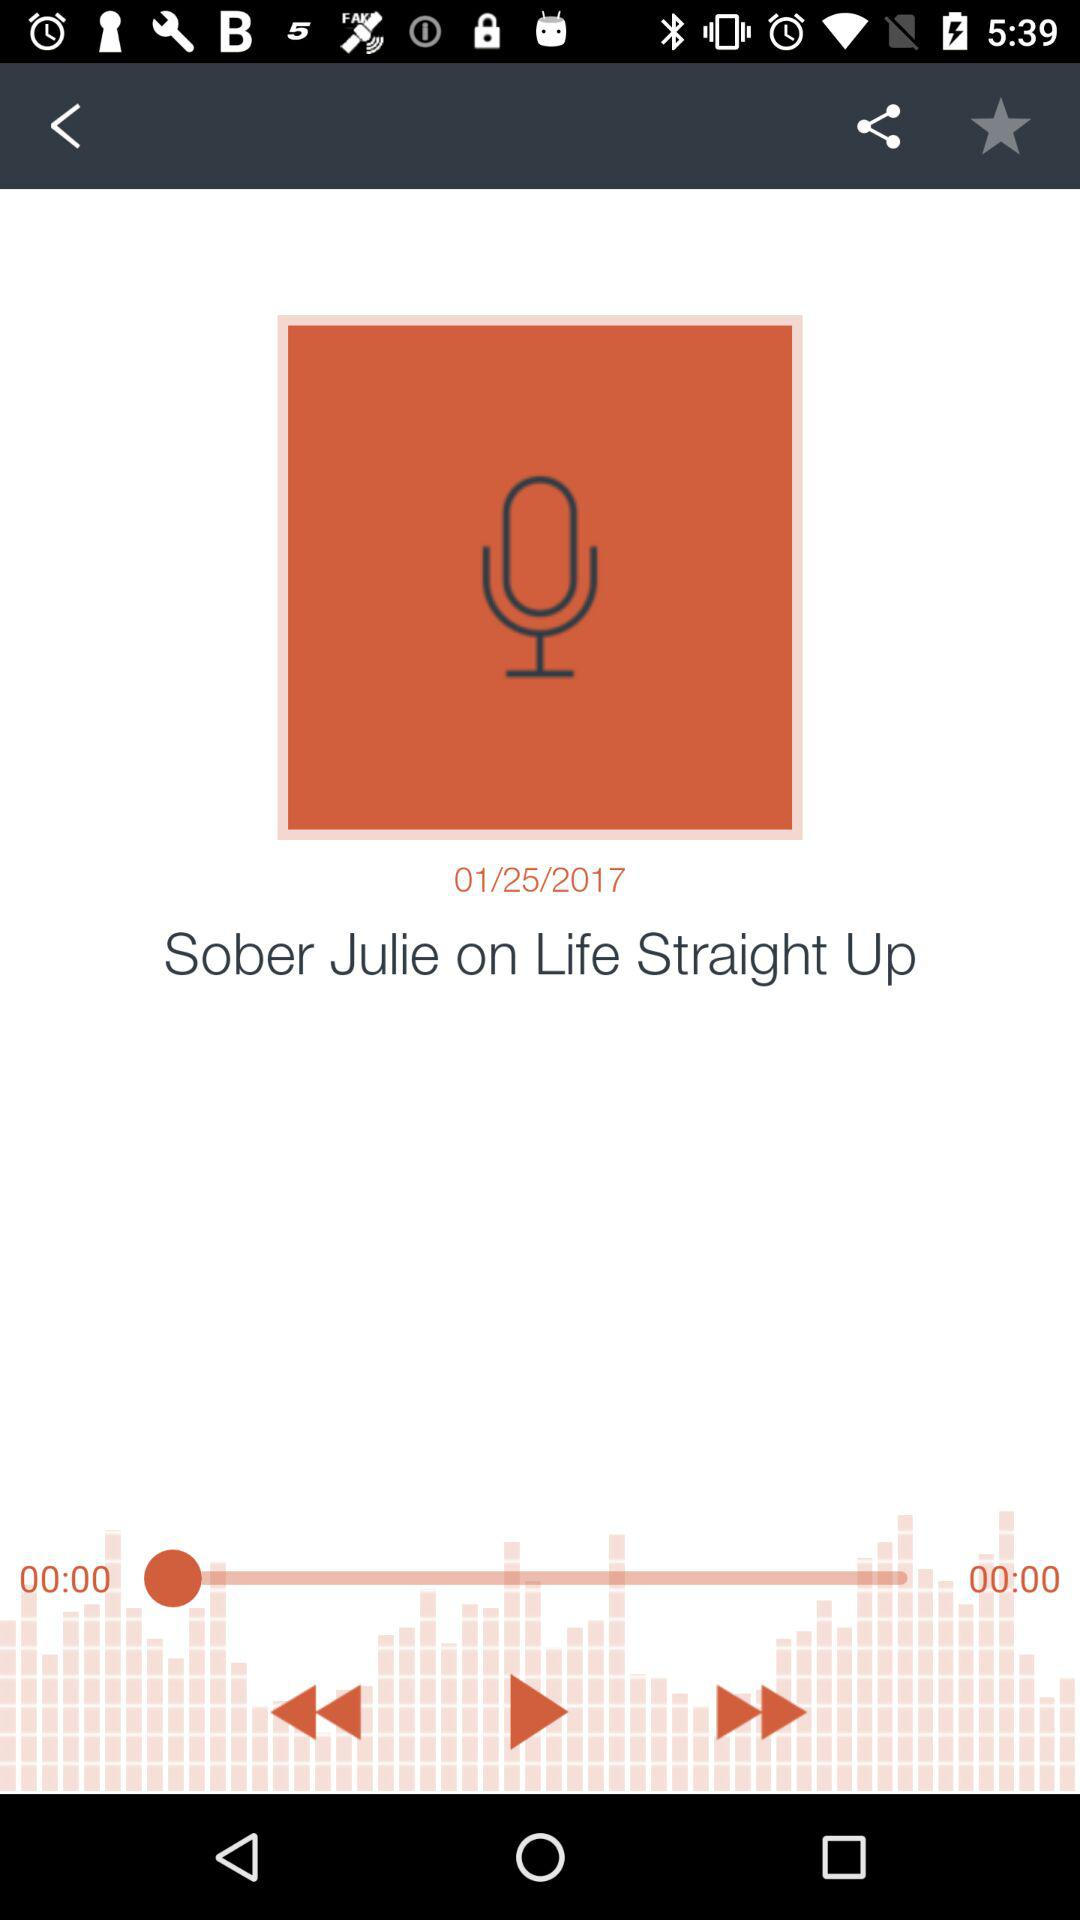What is the name of the application?
When the provided information is insufficient, respond with <no answer>. <no answer> 